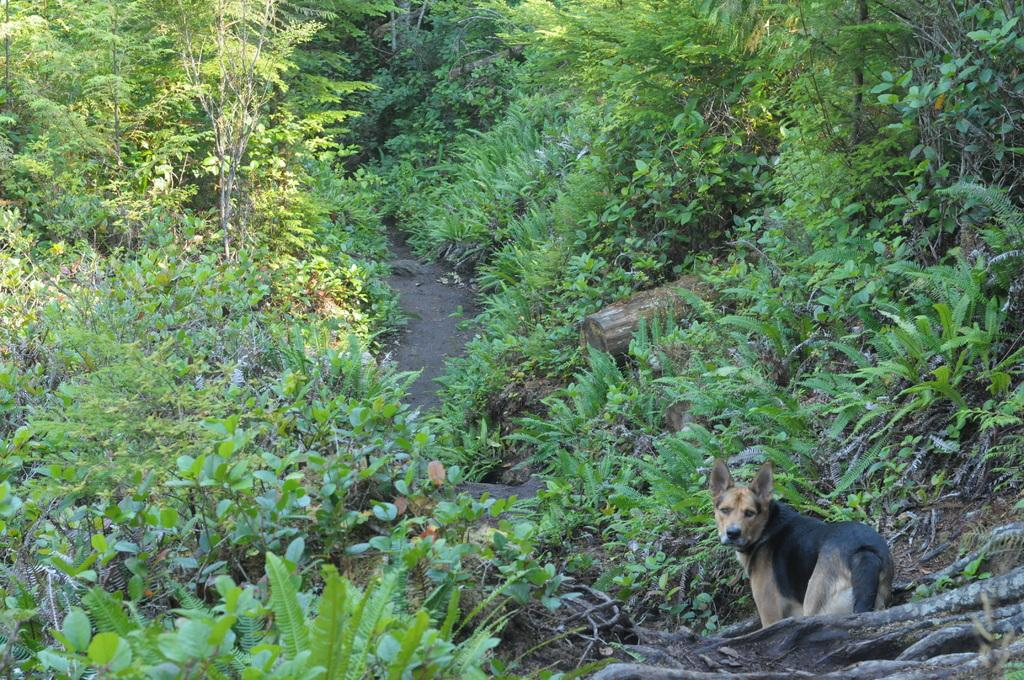What type of animal is at the bottom of the image? There is a dog at the bottom of the image. What can be seen in the background of the image? There are plants and trees in the background of the image. What type of plastic material is visible in the image? There is no plastic material visible in the image. What type of steel structure can be seen in the image? There is no steel structure present in the image. 